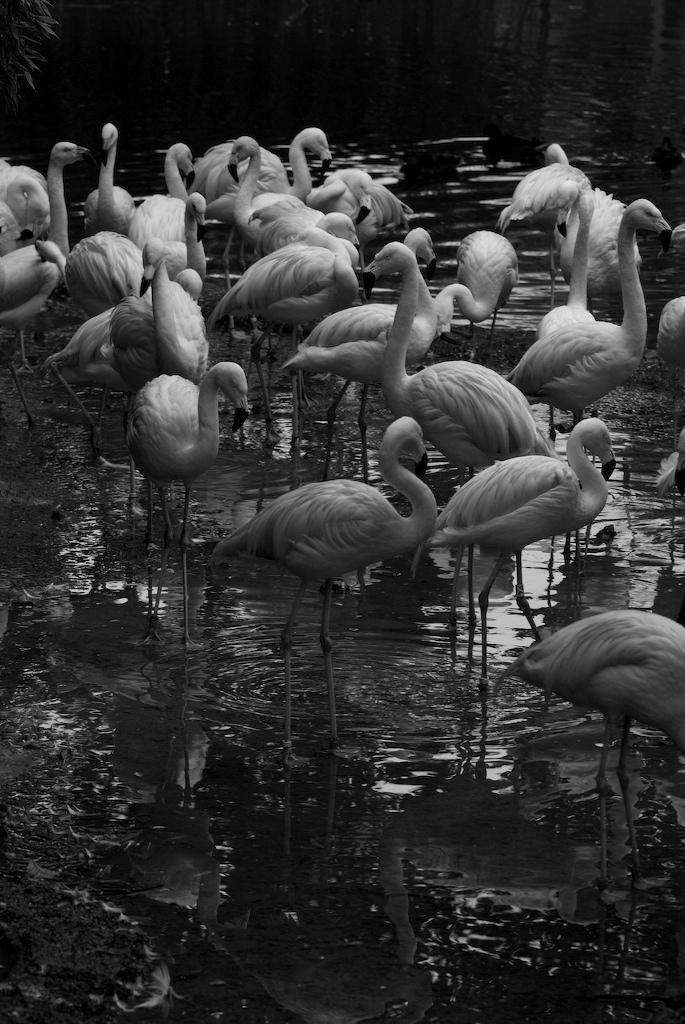In one or two sentences, can you explain what this image depicts? This is a black and white image. In this picture we can see the cranes. In the background of the image we can see the water. In the top left corner we can see a plant. 